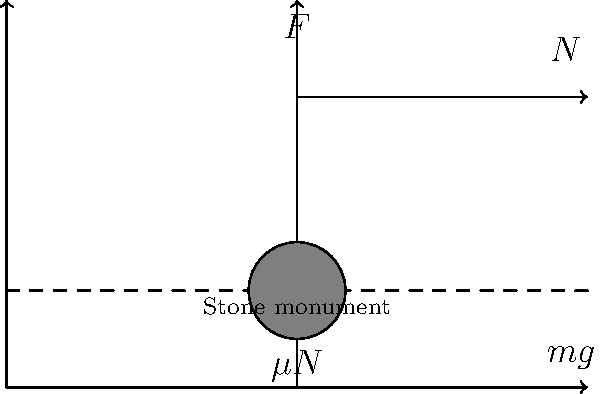As part of a community preservation project, you need to relocate a traditional stone monument weighing 2000 kg. The monument rests on a flat surface with a coefficient of static friction $\mu_s = 0.4$ and coefficient of kinetic friction $\mu_k = 0.3$. Calculate the minimum horizontal force required to start moving the monument. To solve this problem, we'll follow these steps:

1) First, we need to calculate the normal force ($N$). Since the surface is flat, the normal force is equal to the weight of the monument:

   $N = mg = 2000 \text{ kg} \times 9.8 \text{ m/s}^2 = 19600 \text{ N}$

2) The static friction force ($f_s$) is given by:

   $f_s = \mu_s N = 0.4 \times 19600 \text{ N} = 7840 \text{ N}$

3) To start moving the monument, we need to apply a force that is just greater than the static friction force. Therefore, the minimum force ($F$) required is equal to the static friction force:

   $F = f_s = 7840 \text{ N}$

4) We can verify that this force is indeed the minimum required:
   - If we apply less force, the monument won't move due to static friction.
   - If we apply this exact force or slightly more, the monument will just begin to move.
   - Once moving, a smaller force would be needed to keep it in motion, as kinetic friction ($\mu_k N = 0.3 \times 19600 = 5880 \text{ N}$) is less than static friction.

Therefore, the minimum horizontal force required to start moving the monument is 7840 N.
Answer: 7840 N 